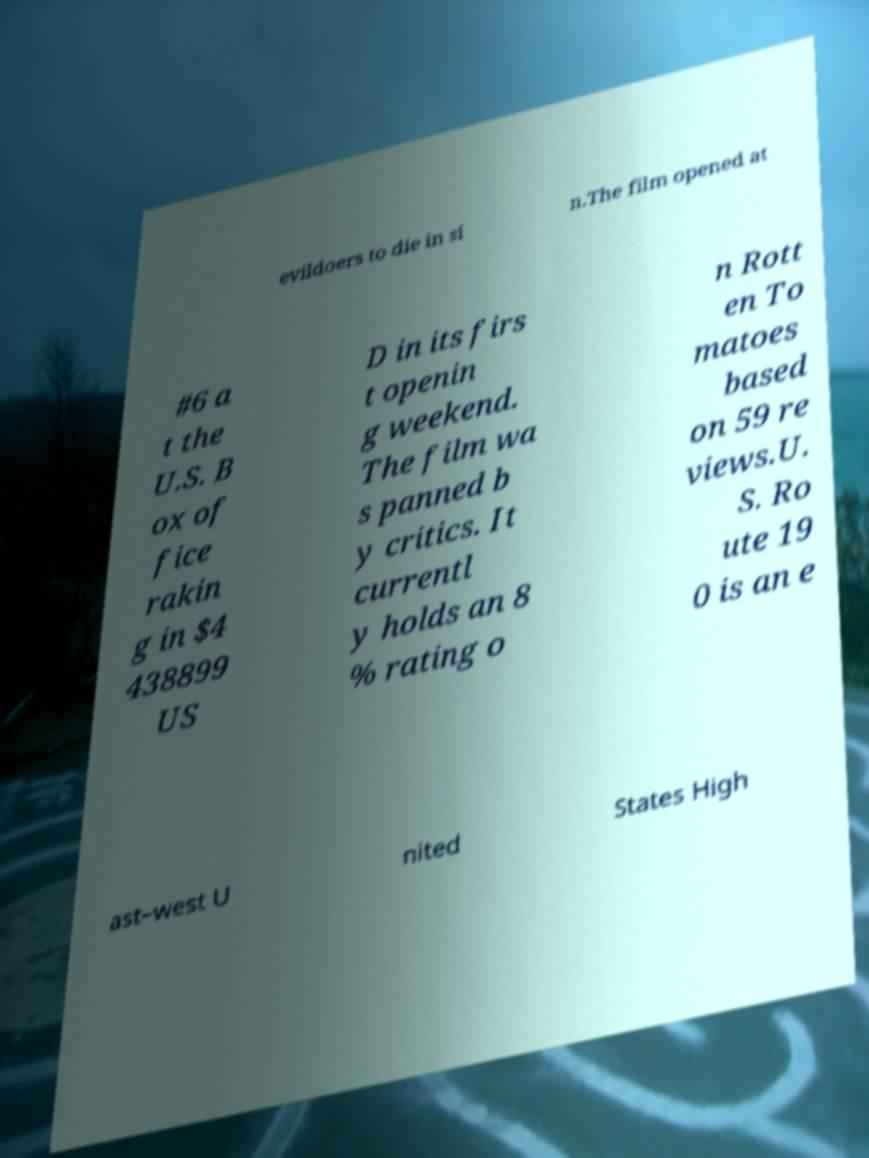I need the written content from this picture converted into text. Can you do that? evildoers to die in si n.The film opened at #6 a t the U.S. B ox of fice rakin g in $4 438899 US D in its firs t openin g weekend. The film wa s panned b y critics. It currentl y holds an 8 % rating o n Rott en To matoes based on 59 re views.U. S. Ro ute 19 0 is an e ast–west U nited States High 